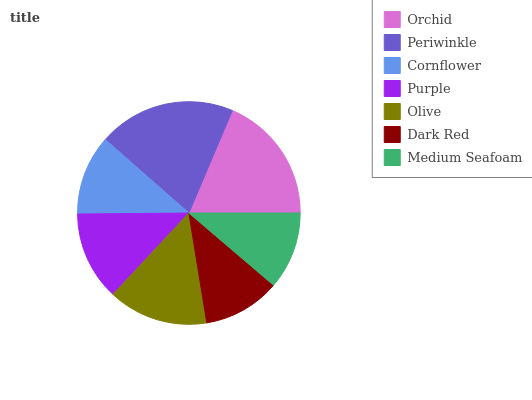Is Dark Red the minimum?
Answer yes or no. Yes. Is Periwinkle the maximum?
Answer yes or no. Yes. Is Cornflower the minimum?
Answer yes or no. No. Is Cornflower the maximum?
Answer yes or no. No. Is Periwinkle greater than Cornflower?
Answer yes or no. Yes. Is Cornflower less than Periwinkle?
Answer yes or no. Yes. Is Cornflower greater than Periwinkle?
Answer yes or no. No. Is Periwinkle less than Cornflower?
Answer yes or no. No. Is Purple the high median?
Answer yes or no. Yes. Is Purple the low median?
Answer yes or no. Yes. Is Olive the high median?
Answer yes or no. No. Is Olive the low median?
Answer yes or no. No. 